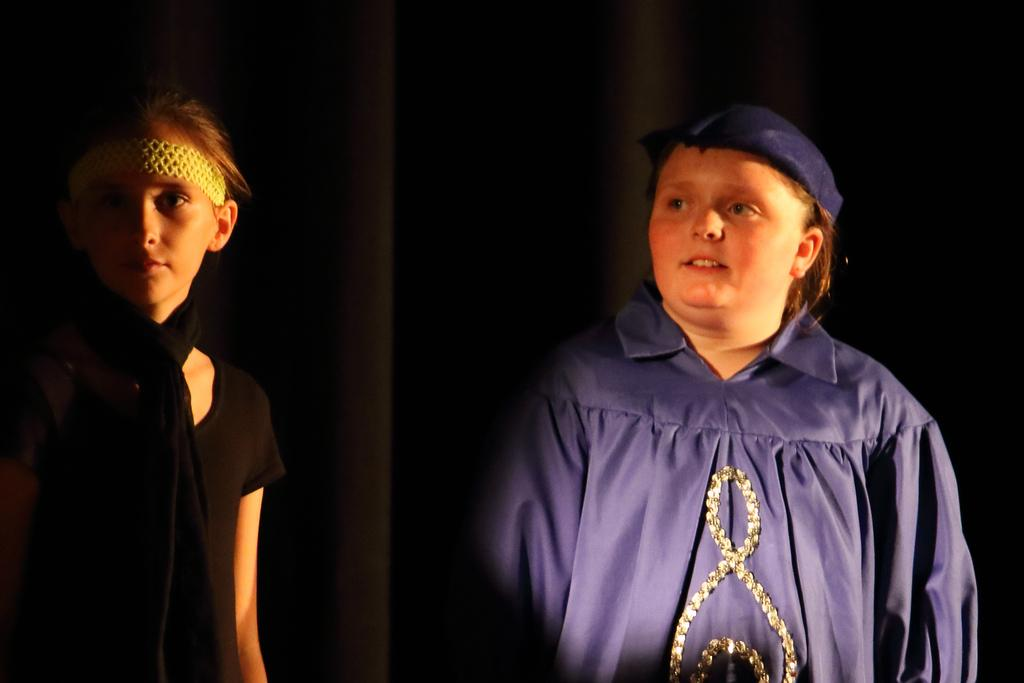How many kids are in the foreground of the picture? There are two kids in the foreground of the picture. What colors are the dresses of the kids? One kid is wearing a black dress, and the other kid is wearing a violet dress. What type of legal advice is the kid in the black dress providing in the image? There is no indication in the image that the kids are providing legal advice or interacting with a lawyer. 